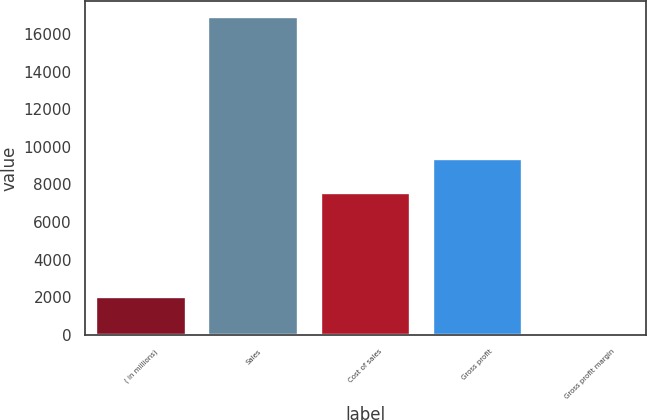Convert chart to OTSL. <chart><loc_0><loc_0><loc_500><loc_500><bar_chart><fcel>( in millions)<fcel>Sales<fcel>Cost of sales<fcel>Gross profit<fcel>Gross profit margin<nl><fcel>2016<fcel>16882.4<fcel>7547.8<fcel>9334.6<fcel>55.3<nl></chart> 